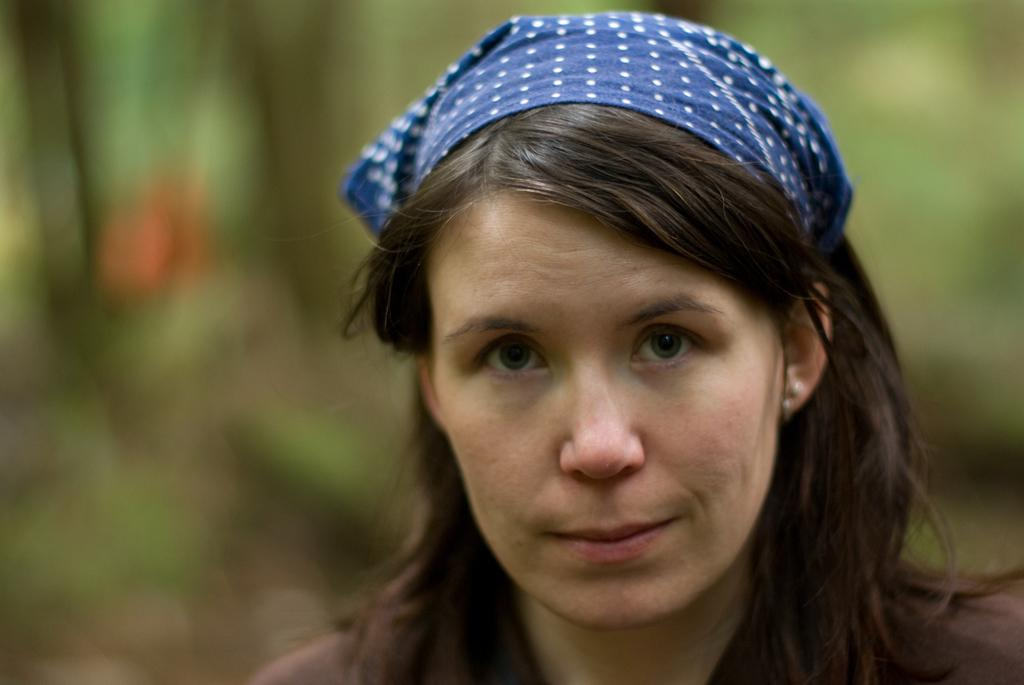Who is the main subject in the image? There is a woman in the image. Can you describe the background of the image? The background of the woman is blurred. What type of surprise can be seen on the woman's face in the image? There is no indication of a surprise or any facial expression on the woman's face in the image, as it is not visible due to the blurred background. 